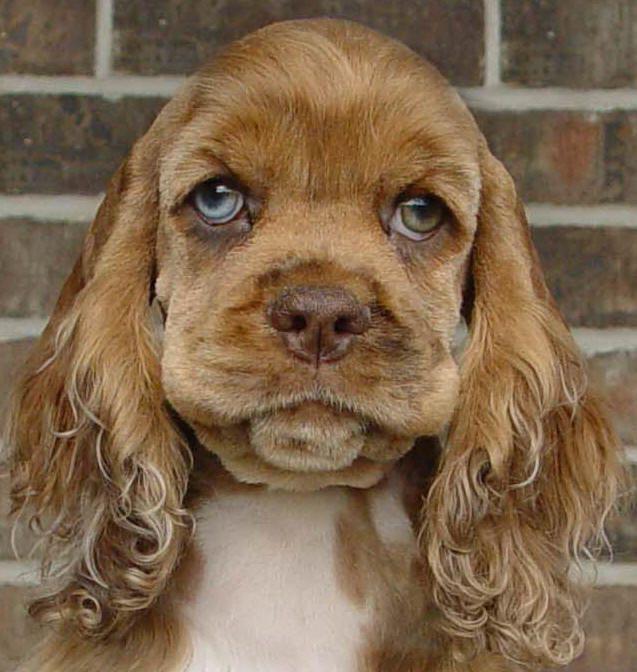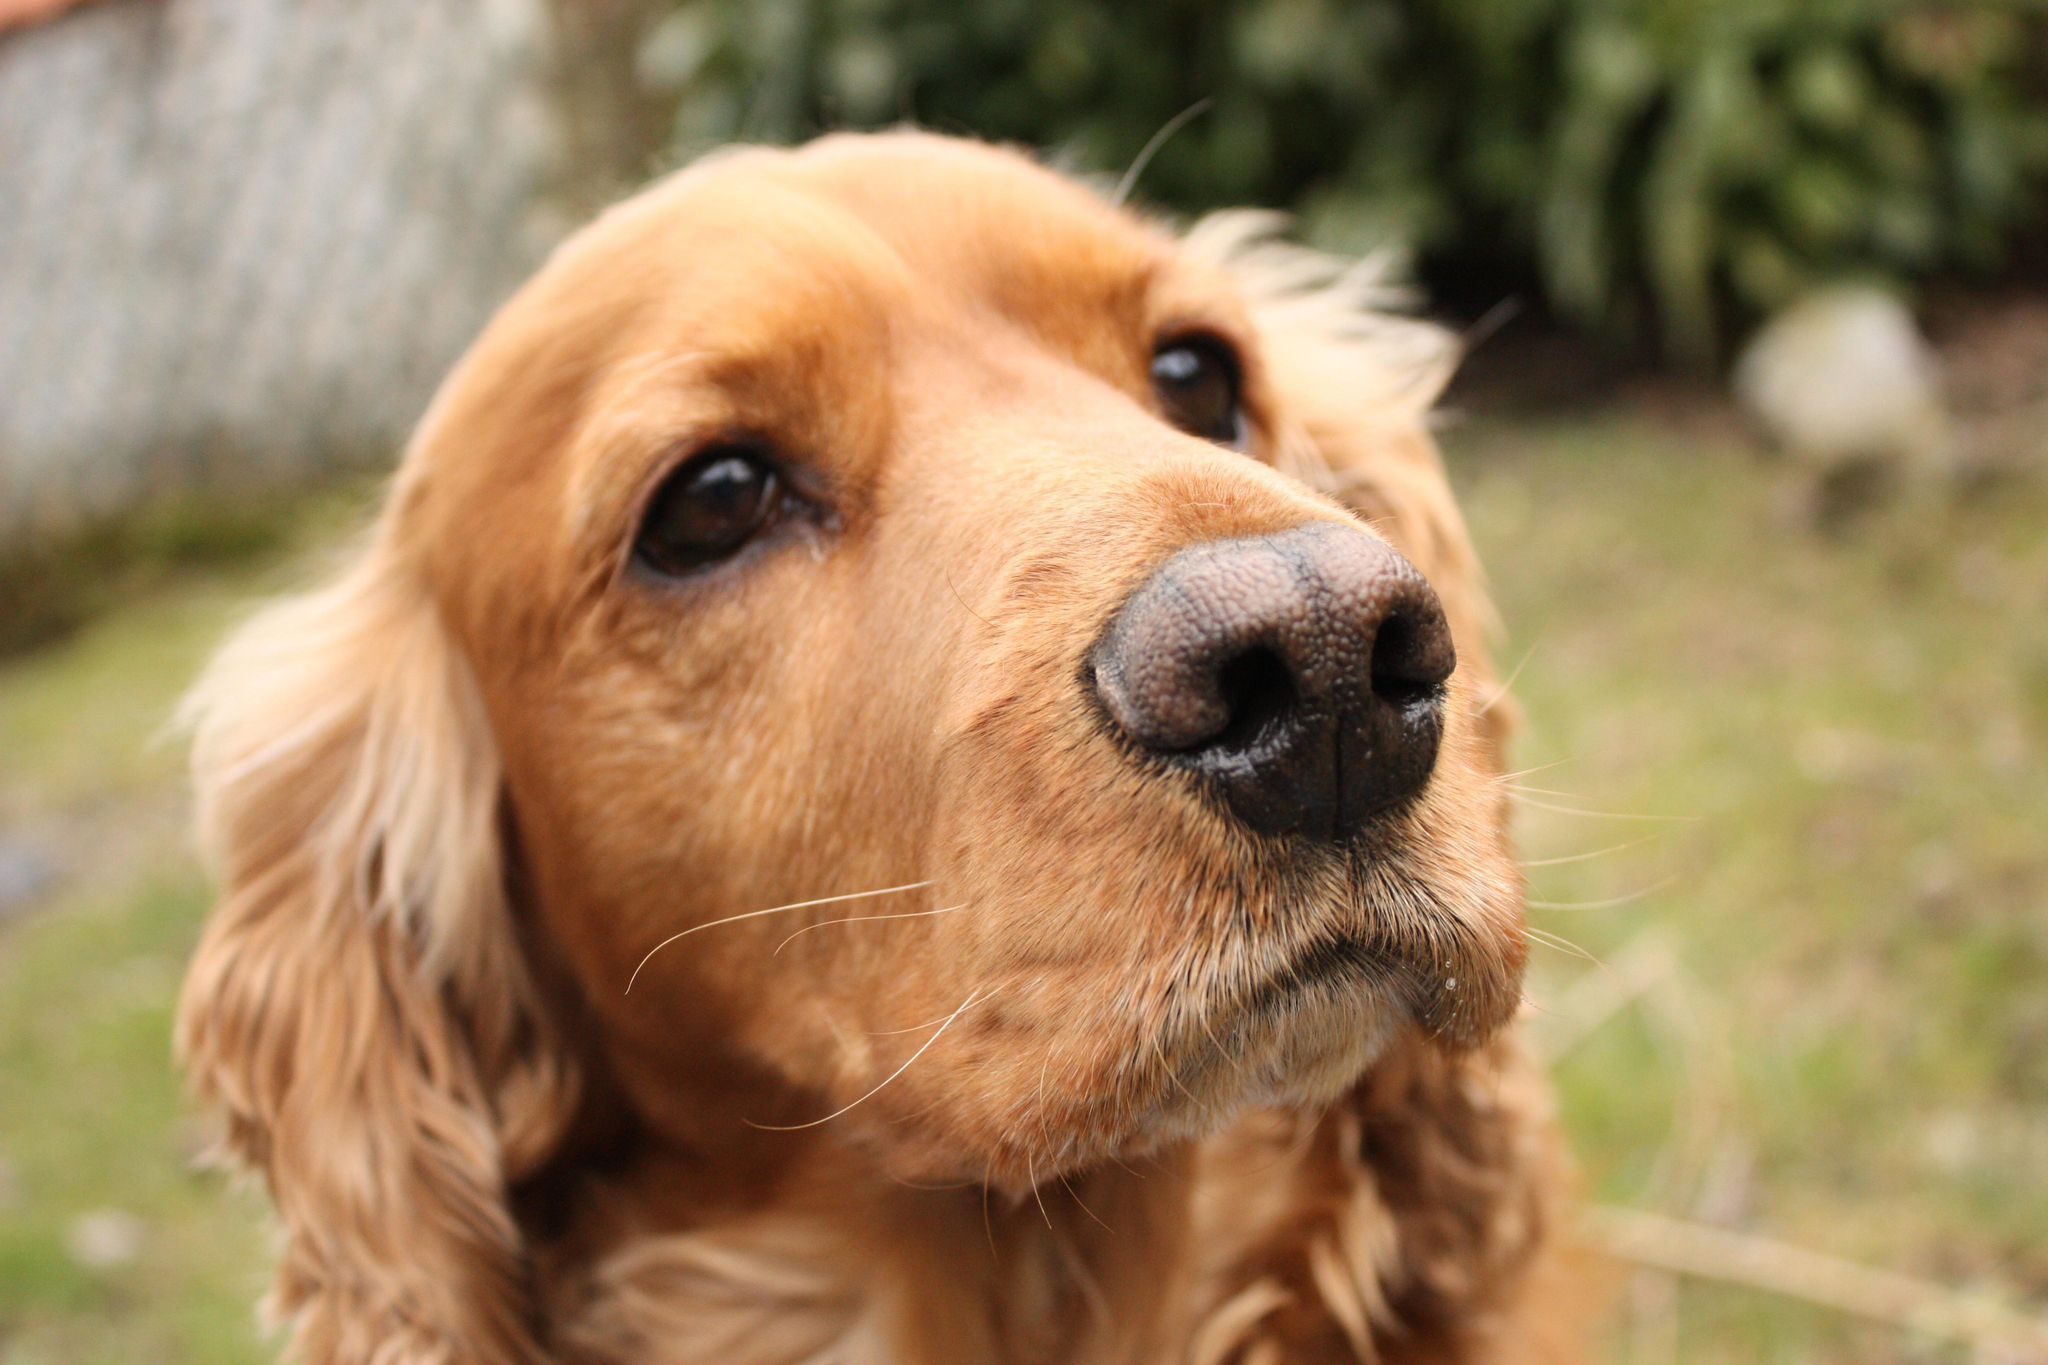The first image is the image on the left, the second image is the image on the right. For the images shown, is this caption "At least one of the dogs is laying down." true? Answer yes or no. No. 